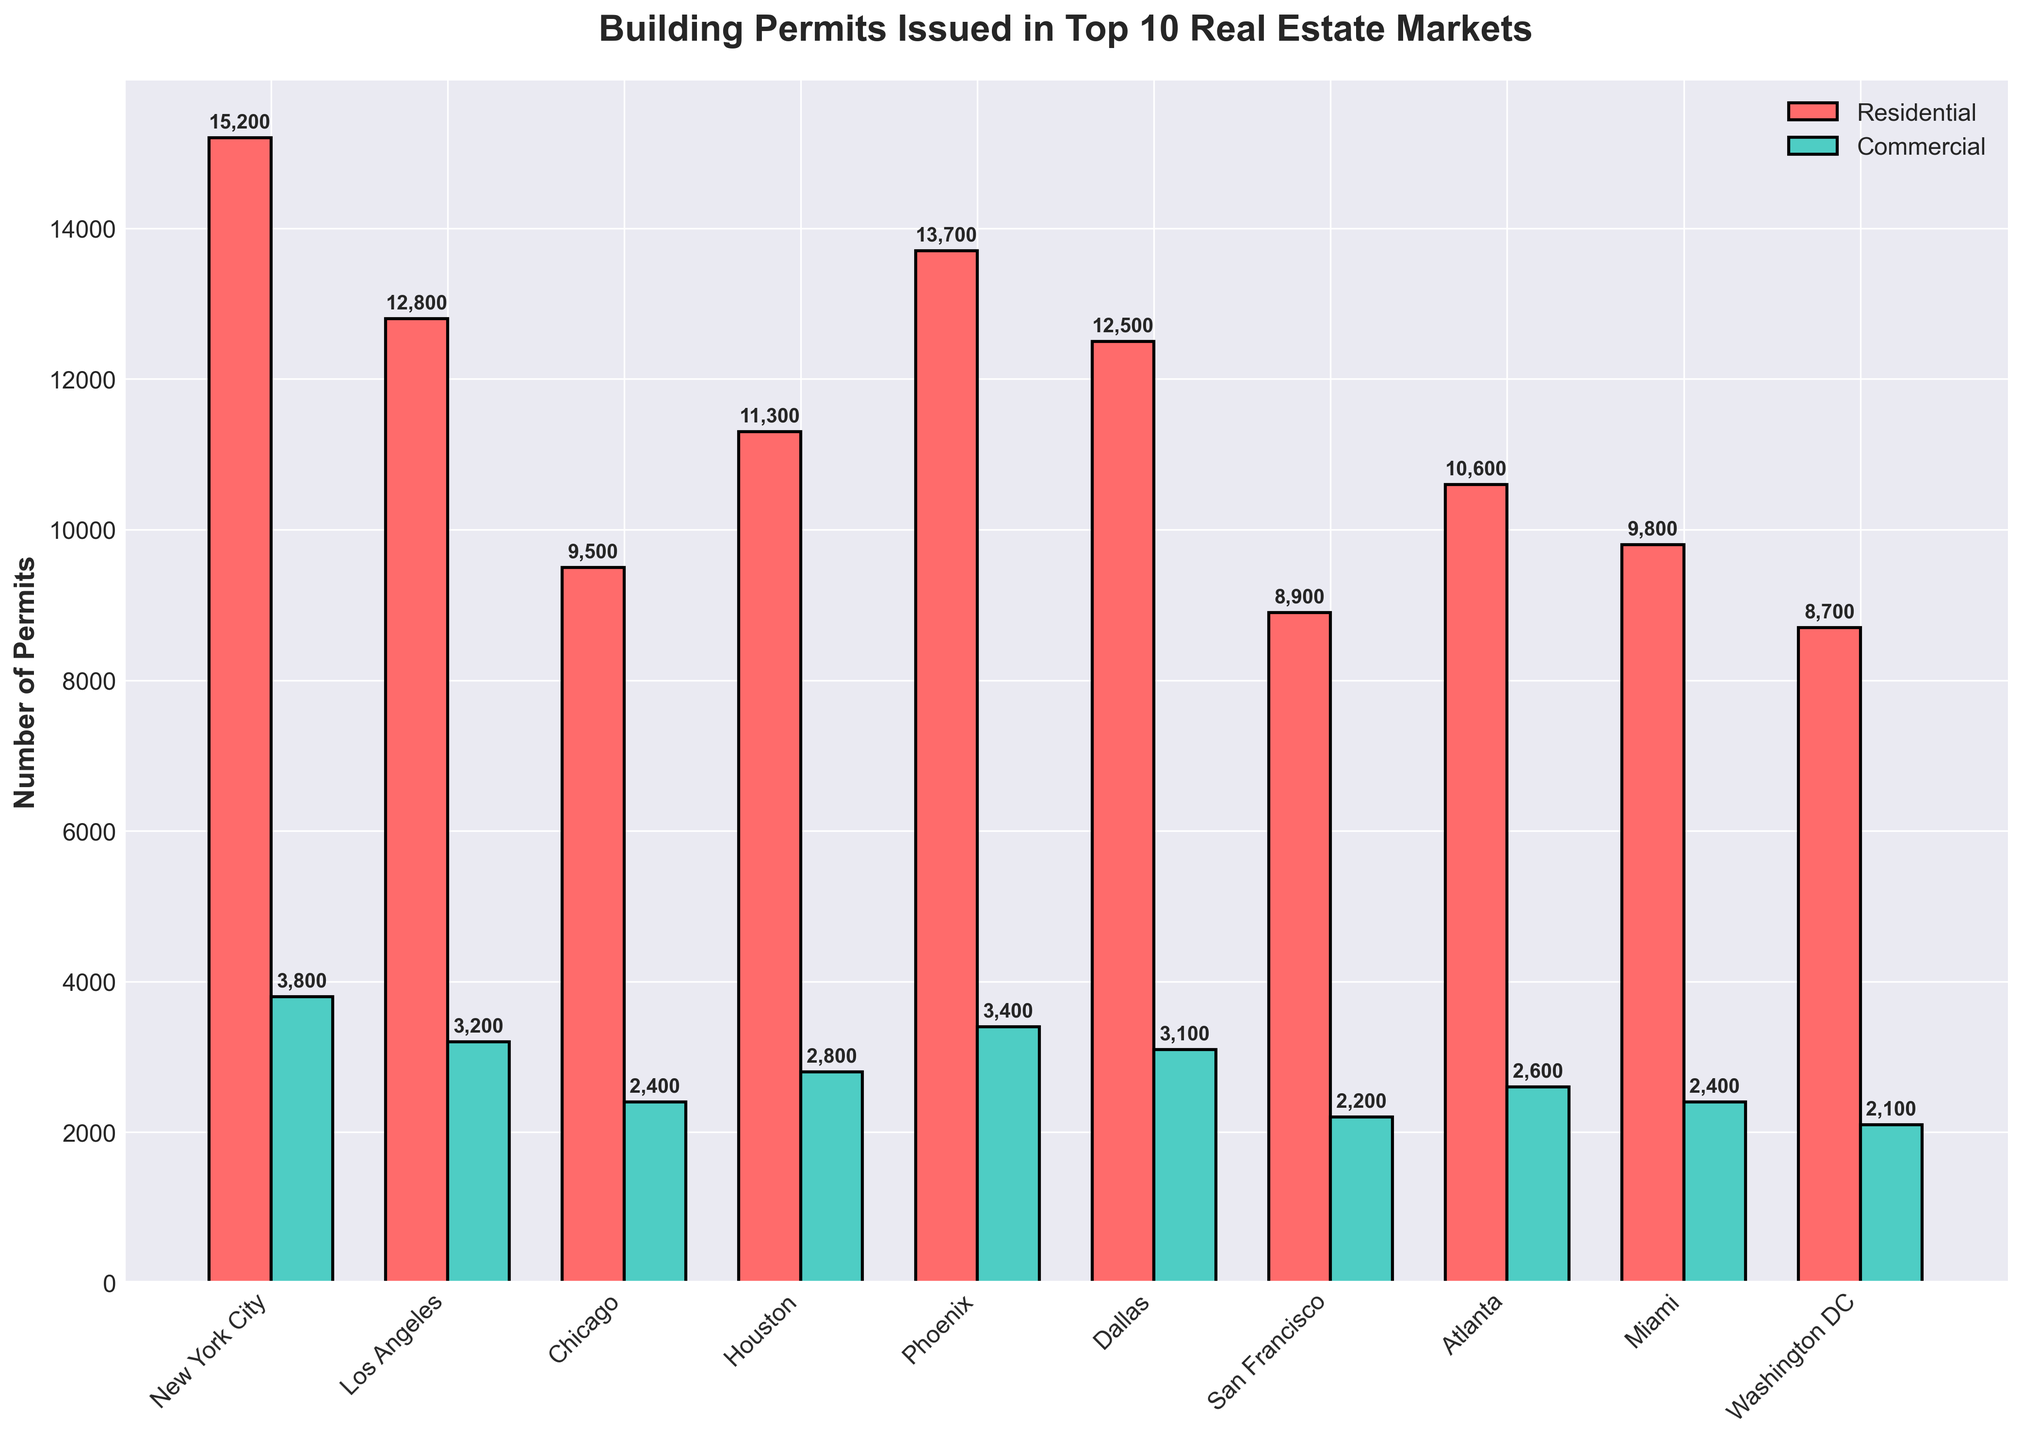Which market issued the most residential permits? The market with the tallest red bar represents the highest number of residential permits issued.
Answer: New York City Which market issued the fewest commercial permits? The market with the shortest green bar represents the fewest commercial permits issued.
Answer: Washington DC How many more residential permits were issued in Phoenix compared to Atlanta? The number of residential permits issued in Phoenix is 13,700, and in Atlanta, it is 10,600. Subtract the smaller from the larger number. 13,700 - 10,600 = 3,100.
Answer: 3,100 Which market has a greater difference between the number of residential and commercial permits: Chicago or Dallas? For Chicago, the difference is 9,500 (residential) - 2,400 (commercial) = 7,100. For Dallas, it is 12,500 (residential) - 3,100 (commercial) = 9,400. Compare these two differences.
Answer: Dallas What is the average number of commercial permits issued across the top 10 markets? Sum the number of commercial permits for all top 10 markets and divide by 10. (3,800 + 3,200 + 2,400 + 2,800 + 3,400 + 3,100 + 2,200 + 2,600 + 2,400 + 2,100) / 10 = 2,800
Answer: 2,800 Which market has the most balanced ratio between residential and commercial permits? Calculate the ratio of residential to commercial permits for each market and compare to find the one closest to 1:1.
Answer: Washington DC (Ratio ≈ 4.14) In which market is the difference between the residential and commercial permits the smallest? Subtract the number of commercial permits from the residential permits for each market and find the smallest positive difference.
Answer: Washington DC (8,700 - 2,100 = 6,600) What is the total number of residential permits issued in the top 3 markets? Sum the number of residential permits for New York City, Los Angeles, and Phoenix. 15,200 + 12,800 + 13,700 = 41,700
Answer: 41,700 By how much do the residential permits in New York City exceed the residential permits in Seattle? Subtract the number of residential permits in Seattle from those in New York City. 15,200 - 7,900 = 7,300.
Answer: 7,300 